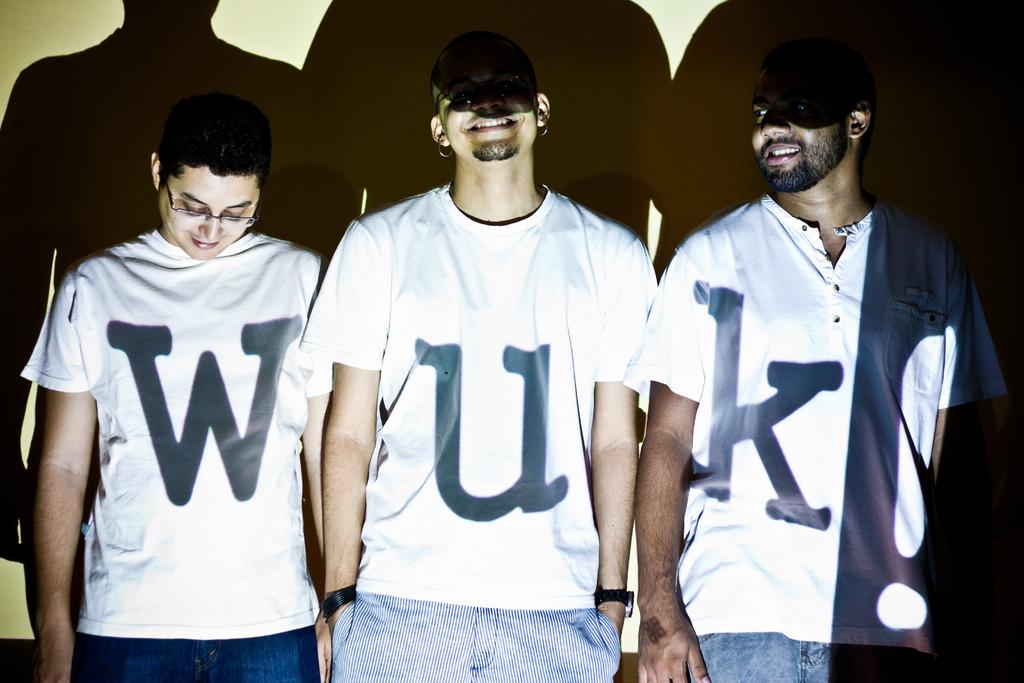What letter is on the shirt of the person standing in the middle?
Ensure brevity in your answer.  U. What do the shirts spell when put together?
Your answer should be compact. Wuk. 